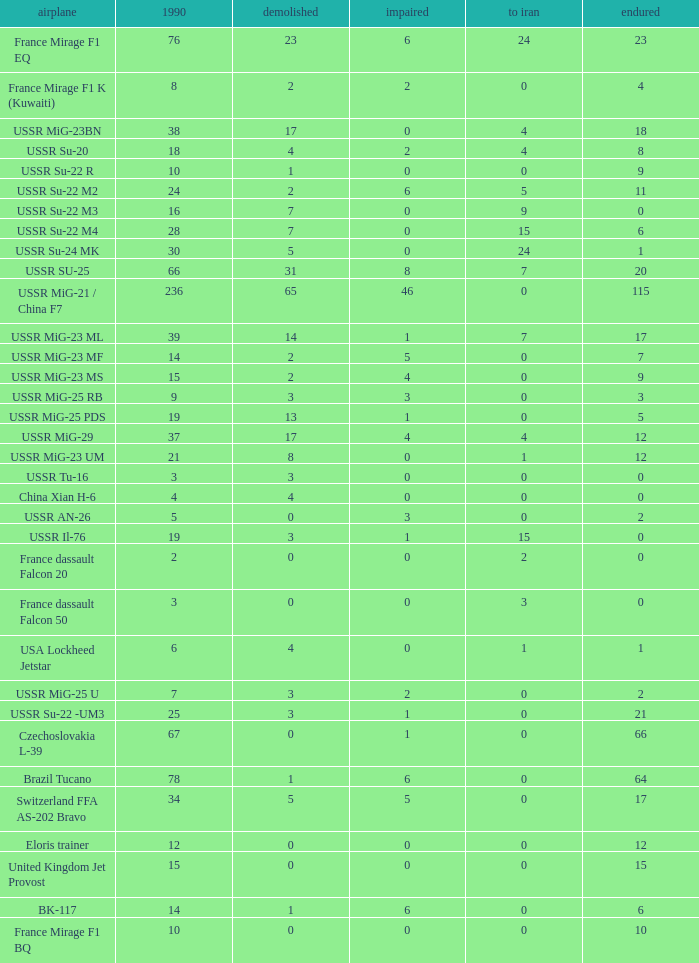If 4 journeyed to iran and the sum that remained was beneath 1 1.0. 